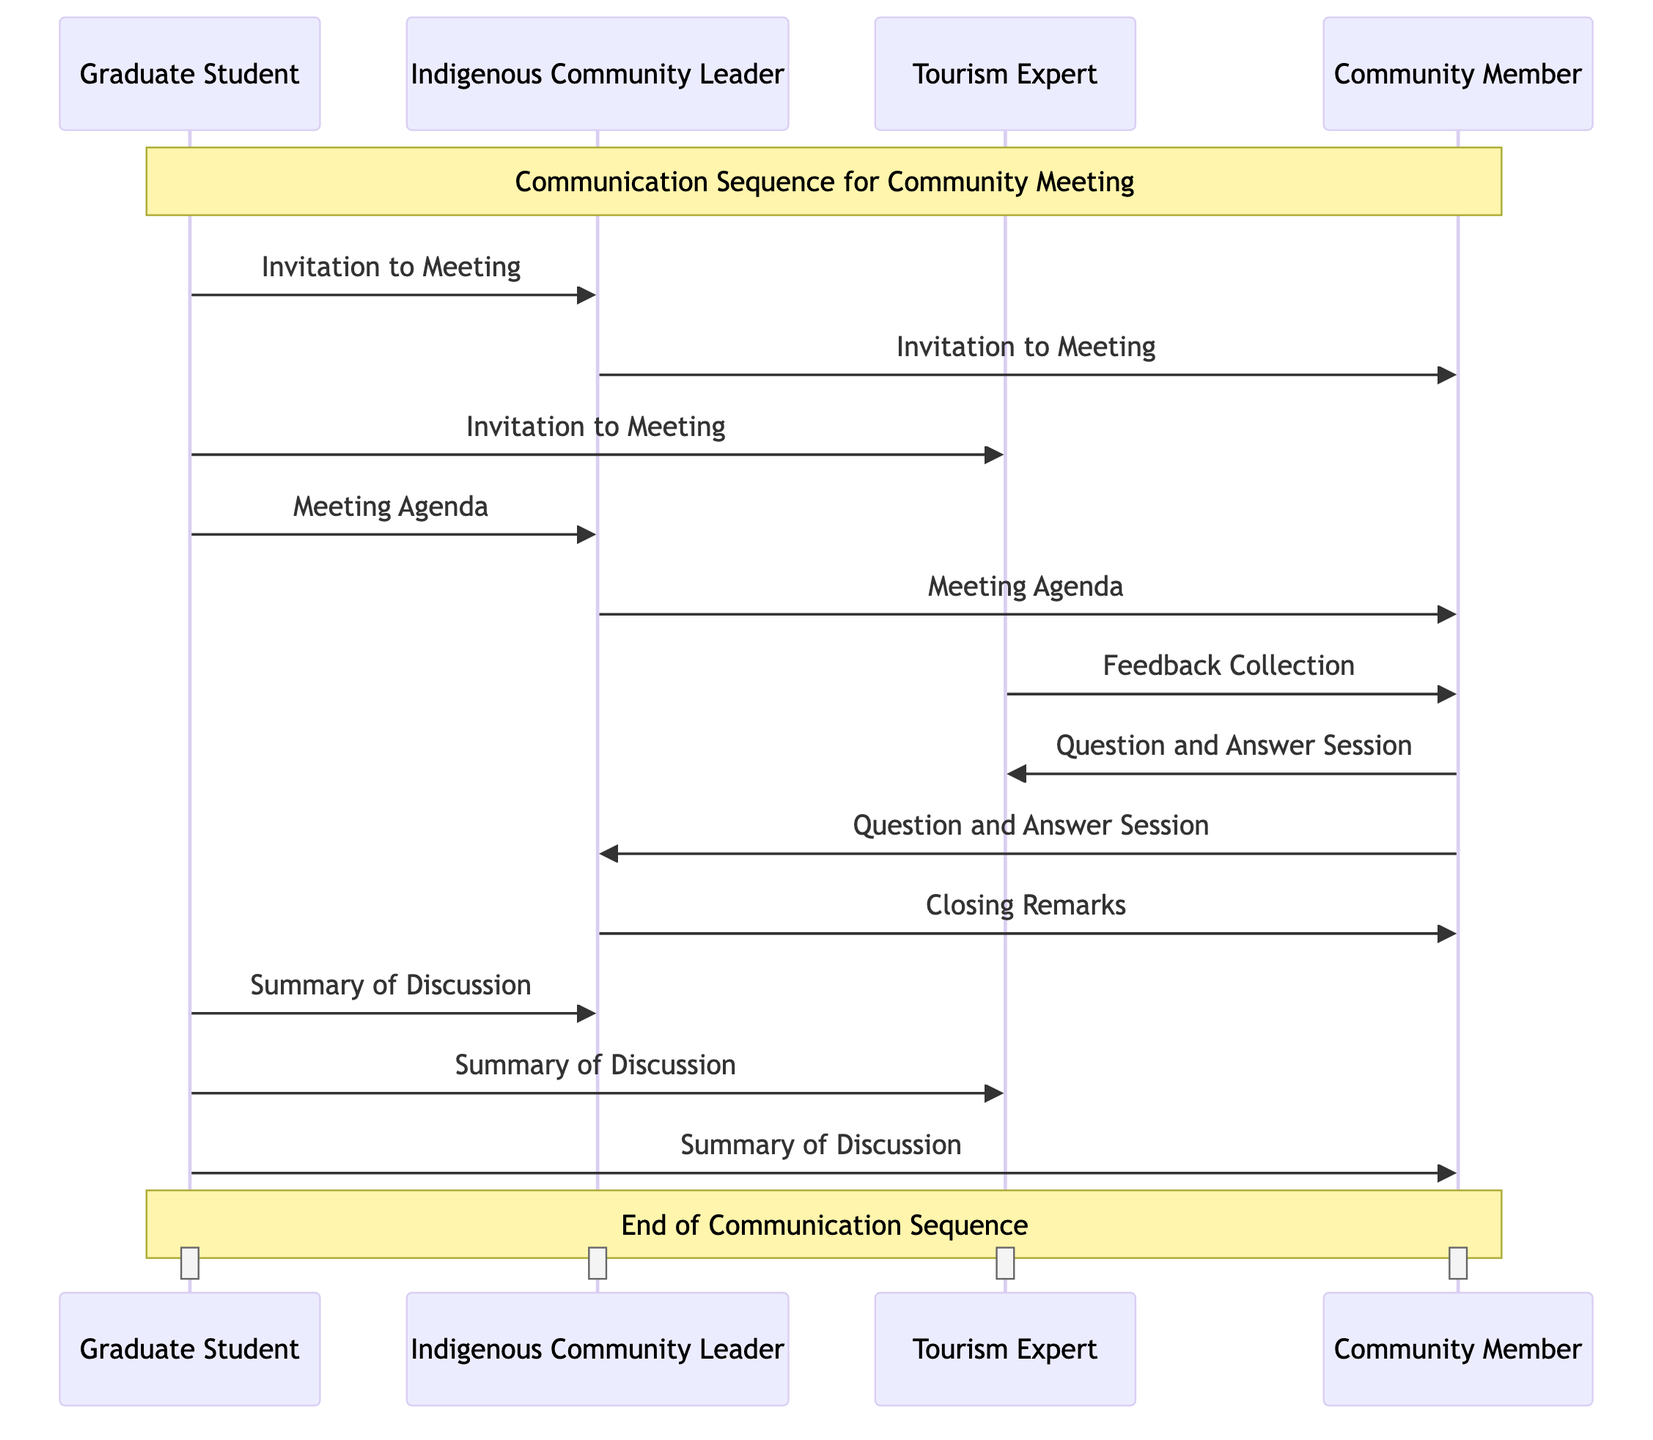What are the participants involved in the communication sequence? The diagram lists four participants: Graduate Student, Indigenous Community Leader, Tourism Expert, and Community Member. These entities are involved in the communication process depicted.
Answer: Graduate Student, Indigenous Community Leader, Tourism Expert, Community Member How many messages are exchanged in the sequence? The diagram shows a total of six messages exchanged between the participants: Invitation to Meeting, Meeting Agenda, Feedback Collection, Question and Answer Session, Closing Remarks, and Summary of Discussion. By counting these messages, we find the total.
Answer: Six Who sends the "Meeting Agenda" message to the Community Member? The Indigenous Community Leader sends the "Meeting Agenda" message to the Community Member according to the flow of messages in the diagram. This inter-person communication is shown directly in the sequence.
Answer: Indigenous Community Leader Which participant collects feedback from the Community Member? The Tourism Expert is responsible for collecting feedback from the Community Member, as indicated by the flow of the message titled "Feedback Collection."
Answer: Tourism Expert What is the final message sent from the Graduate Student? The final message from the Graduate Student is the "Summary of Discussion." This is the last interaction in the communication sequence, indicating the closure of the meeting discussion.
Answer: Summary of Discussion Which two participants are involved in the "Question and Answer Session"? The Community Member interacts with both the Tourism Expert and the Indigenous Community Leader during the "Question and Answer Session," as depicted by the arrows pointing from the Community Member to these two entities.
Answer: Community Member, Tourism Expert and Indigenous Community Leader How many participants receive the "Invitation to Meeting"? Three participants receive the "Invitation to Meeting": Indigenous Community Leader, Tourism Expert, and Community Member, as indicated by the arrows pointing to these participants from the Graduate Student.
Answer: Three What role does the Indigenous Community Leader play in the meeting? The Indigenous Community Leader acts as a facilitator by extending the invitation to the Community Member, sending out the meeting agenda, and providing closing remarks, indicating their active role in the process.
Answer: Facilitator 